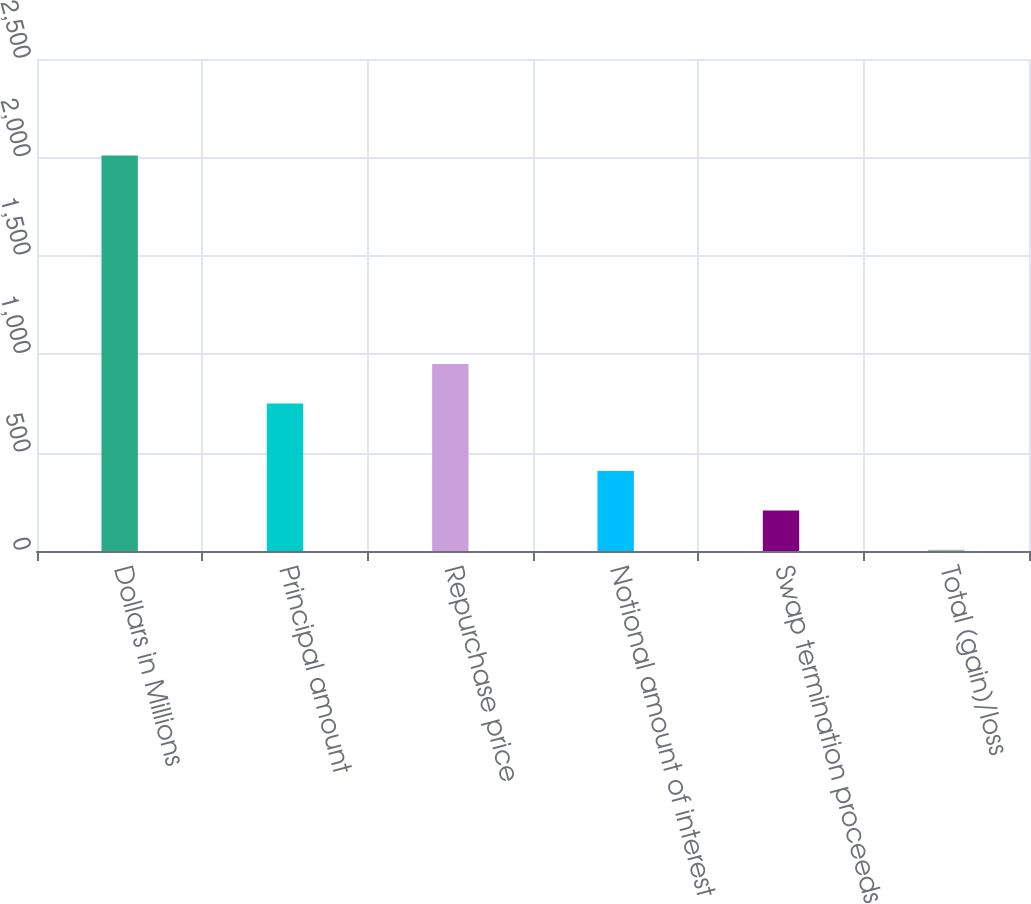Convert chart to OTSL. <chart><loc_0><loc_0><loc_500><loc_500><bar_chart><fcel>Dollars in Millions<fcel>Principal amount<fcel>Repurchase price<fcel>Notional amount of interest<fcel>Swap termination proceeds<fcel>Total (gain)/loss<nl><fcel>2010<fcel>750<fcel>950.4<fcel>406.8<fcel>206.4<fcel>6<nl></chart> 